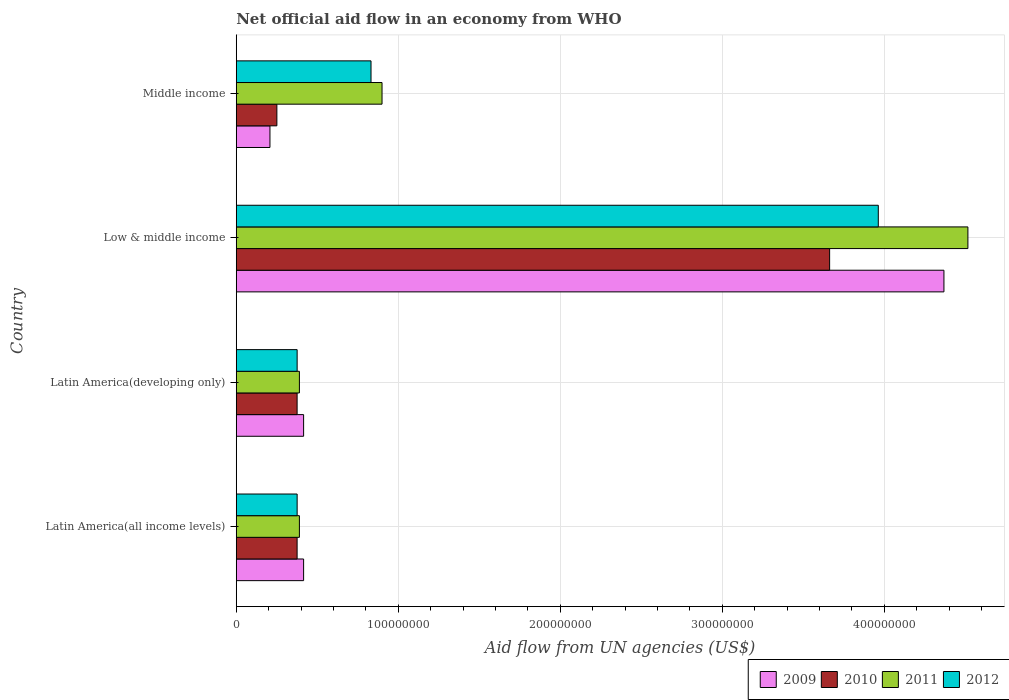How many different coloured bars are there?
Offer a very short reply. 4. Are the number of bars on each tick of the Y-axis equal?
Keep it short and to the point. Yes. What is the label of the 3rd group of bars from the top?
Ensure brevity in your answer.  Latin America(developing only). In how many cases, is the number of bars for a given country not equal to the number of legend labels?
Your answer should be very brief. 0. What is the net official aid flow in 2010 in Middle income?
Offer a terse response. 2.51e+07. Across all countries, what is the maximum net official aid flow in 2009?
Provide a short and direct response. 4.37e+08. Across all countries, what is the minimum net official aid flow in 2009?
Provide a short and direct response. 2.08e+07. In which country was the net official aid flow in 2011 maximum?
Your answer should be compact. Low & middle income. In which country was the net official aid flow in 2011 minimum?
Keep it short and to the point. Latin America(all income levels). What is the total net official aid flow in 2009 in the graph?
Provide a short and direct response. 5.41e+08. What is the difference between the net official aid flow in 2010 in Latin America(developing only) and that in Middle income?
Give a very brief answer. 1.25e+07. What is the difference between the net official aid flow in 2010 in Latin America(all income levels) and the net official aid flow in 2011 in Low & middle income?
Ensure brevity in your answer.  -4.14e+08. What is the average net official aid flow in 2009 per country?
Ensure brevity in your answer.  1.35e+08. What is the difference between the net official aid flow in 2010 and net official aid flow in 2009 in Low & middle income?
Keep it short and to the point. -7.06e+07. What is the ratio of the net official aid flow in 2009 in Low & middle income to that in Middle income?
Keep it short and to the point. 21. Is the net official aid flow in 2009 in Latin America(all income levels) less than that in Latin America(developing only)?
Your response must be concise. No. Is the difference between the net official aid flow in 2010 in Low & middle income and Middle income greater than the difference between the net official aid flow in 2009 in Low & middle income and Middle income?
Make the answer very short. No. What is the difference between the highest and the second highest net official aid flow in 2009?
Keep it short and to the point. 3.95e+08. What is the difference between the highest and the lowest net official aid flow in 2012?
Your answer should be compact. 3.59e+08. Is the sum of the net official aid flow in 2009 in Latin America(developing only) and Middle income greater than the maximum net official aid flow in 2011 across all countries?
Give a very brief answer. No. Is it the case that in every country, the sum of the net official aid flow in 2012 and net official aid flow in 2010 is greater than the sum of net official aid flow in 2011 and net official aid flow in 2009?
Provide a succinct answer. No. How many bars are there?
Offer a terse response. 16. Are all the bars in the graph horizontal?
Your answer should be very brief. Yes. Are the values on the major ticks of X-axis written in scientific E-notation?
Offer a very short reply. No. Does the graph contain any zero values?
Provide a short and direct response. No. Where does the legend appear in the graph?
Keep it short and to the point. Bottom right. What is the title of the graph?
Make the answer very short. Net official aid flow in an economy from WHO. What is the label or title of the X-axis?
Your response must be concise. Aid flow from UN agencies (US$). What is the Aid flow from UN agencies (US$) of 2009 in Latin America(all income levels)?
Make the answer very short. 4.16e+07. What is the Aid flow from UN agencies (US$) in 2010 in Latin America(all income levels)?
Offer a terse response. 3.76e+07. What is the Aid flow from UN agencies (US$) in 2011 in Latin America(all income levels)?
Keep it short and to the point. 3.90e+07. What is the Aid flow from UN agencies (US$) of 2012 in Latin America(all income levels)?
Your answer should be compact. 3.76e+07. What is the Aid flow from UN agencies (US$) of 2009 in Latin America(developing only)?
Keep it short and to the point. 4.16e+07. What is the Aid flow from UN agencies (US$) in 2010 in Latin America(developing only)?
Offer a terse response. 3.76e+07. What is the Aid flow from UN agencies (US$) in 2011 in Latin America(developing only)?
Ensure brevity in your answer.  3.90e+07. What is the Aid flow from UN agencies (US$) of 2012 in Latin America(developing only)?
Give a very brief answer. 3.76e+07. What is the Aid flow from UN agencies (US$) of 2009 in Low & middle income?
Provide a succinct answer. 4.37e+08. What is the Aid flow from UN agencies (US$) in 2010 in Low & middle income?
Offer a terse response. 3.66e+08. What is the Aid flow from UN agencies (US$) of 2011 in Low & middle income?
Your response must be concise. 4.52e+08. What is the Aid flow from UN agencies (US$) in 2012 in Low & middle income?
Make the answer very short. 3.96e+08. What is the Aid flow from UN agencies (US$) of 2009 in Middle income?
Make the answer very short. 2.08e+07. What is the Aid flow from UN agencies (US$) of 2010 in Middle income?
Your response must be concise. 2.51e+07. What is the Aid flow from UN agencies (US$) in 2011 in Middle income?
Give a very brief answer. 9.00e+07. What is the Aid flow from UN agencies (US$) of 2012 in Middle income?
Offer a very short reply. 8.32e+07. Across all countries, what is the maximum Aid flow from UN agencies (US$) of 2009?
Ensure brevity in your answer.  4.37e+08. Across all countries, what is the maximum Aid flow from UN agencies (US$) of 2010?
Your answer should be very brief. 3.66e+08. Across all countries, what is the maximum Aid flow from UN agencies (US$) of 2011?
Offer a very short reply. 4.52e+08. Across all countries, what is the maximum Aid flow from UN agencies (US$) in 2012?
Your answer should be compact. 3.96e+08. Across all countries, what is the minimum Aid flow from UN agencies (US$) in 2009?
Ensure brevity in your answer.  2.08e+07. Across all countries, what is the minimum Aid flow from UN agencies (US$) of 2010?
Provide a succinct answer. 2.51e+07. Across all countries, what is the minimum Aid flow from UN agencies (US$) in 2011?
Your answer should be very brief. 3.90e+07. Across all countries, what is the minimum Aid flow from UN agencies (US$) of 2012?
Make the answer very short. 3.76e+07. What is the total Aid flow from UN agencies (US$) of 2009 in the graph?
Your response must be concise. 5.41e+08. What is the total Aid flow from UN agencies (US$) of 2010 in the graph?
Offer a very short reply. 4.66e+08. What is the total Aid flow from UN agencies (US$) in 2011 in the graph?
Keep it short and to the point. 6.20e+08. What is the total Aid flow from UN agencies (US$) of 2012 in the graph?
Provide a short and direct response. 5.55e+08. What is the difference between the Aid flow from UN agencies (US$) of 2010 in Latin America(all income levels) and that in Latin America(developing only)?
Offer a terse response. 0. What is the difference between the Aid flow from UN agencies (US$) of 2009 in Latin America(all income levels) and that in Low & middle income?
Your answer should be very brief. -3.95e+08. What is the difference between the Aid flow from UN agencies (US$) of 2010 in Latin America(all income levels) and that in Low & middle income?
Your answer should be compact. -3.29e+08. What is the difference between the Aid flow from UN agencies (US$) in 2011 in Latin America(all income levels) and that in Low & middle income?
Provide a succinct answer. -4.13e+08. What is the difference between the Aid flow from UN agencies (US$) in 2012 in Latin America(all income levels) and that in Low & middle income?
Keep it short and to the point. -3.59e+08. What is the difference between the Aid flow from UN agencies (US$) in 2009 in Latin America(all income levels) and that in Middle income?
Your answer should be compact. 2.08e+07. What is the difference between the Aid flow from UN agencies (US$) of 2010 in Latin America(all income levels) and that in Middle income?
Ensure brevity in your answer.  1.25e+07. What is the difference between the Aid flow from UN agencies (US$) in 2011 in Latin America(all income levels) and that in Middle income?
Keep it short and to the point. -5.10e+07. What is the difference between the Aid flow from UN agencies (US$) of 2012 in Latin America(all income levels) and that in Middle income?
Provide a succinct answer. -4.56e+07. What is the difference between the Aid flow from UN agencies (US$) of 2009 in Latin America(developing only) and that in Low & middle income?
Your answer should be very brief. -3.95e+08. What is the difference between the Aid flow from UN agencies (US$) of 2010 in Latin America(developing only) and that in Low & middle income?
Offer a terse response. -3.29e+08. What is the difference between the Aid flow from UN agencies (US$) of 2011 in Latin America(developing only) and that in Low & middle income?
Offer a terse response. -4.13e+08. What is the difference between the Aid flow from UN agencies (US$) of 2012 in Latin America(developing only) and that in Low & middle income?
Your answer should be very brief. -3.59e+08. What is the difference between the Aid flow from UN agencies (US$) in 2009 in Latin America(developing only) and that in Middle income?
Keep it short and to the point. 2.08e+07. What is the difference between the Aid flow from UN agencies (US$) in 2010 in Latin America(developing only) and that in Middle income?
Give a very brief answer. 1.25e+07. What is the difference between the Aid flow from UN agencies (US$) in 2011 in Latin America(developing only) and that in Middle income?
Offer a very short reply. -5.10e+07. What is the difference between the Aid flow from UN agencies (US$) in 2012 in Latin America(developing only) and that in Middle income?
Ensure brevity in your answer.  -4.56e+07. What is the difference between the Aid flow from UN agencies (US$) in 2009 in Low & middle income and that in Middle income?
Your answer should be very brief. 4.16e+08. What is the difference between the Aid flow from UN agencies (US$) of 2010 in Low & middle income and that in Middle income?
Make the answer very short. 3.41e+08. What is the difference between the Aid flow from UN agencies (US$) in 2011 in Low & middle income and that in Middle income?
Your answer should be compact. 3.62e+08. What is the difference between the Aid flow from UN agencies (US$) of 2012 in Low & middle income and that in Middle income?
Ensure brevity in your answer.  3.13e+08. What is the difference between the Aid flow from UN agencies (US$) in 2009 in Latin America(all income levels) and the Aid flow from UN agencies (US$) in 2010 in Latin America(developing only)?
Offer a terse response. 4.01e+06. What is the difference between the Aid flow from UN agencies (US$) in 2009 in Latin America(all income levels) and the Aid flow from UN agencies (US$) in 2011 in Latin America(developing only)?
Offer a very short reply. 2.59e+06. What is the difference between the Aid flow from UN agencies (US$) in 2009 in Latin America(all income levels) and the Aid flow from UN agencies (US$) in 2012 in Latin America(developing only)?
Ensure brevity in your answer.  3.99e+06. What is the difference between the Aid flow from UN agencies (US$) in 2010 in Latin America(all income levels) and the Aid flow from UN agencies (US$) in 2011 in Latin America(developing only)?
Your answer should be compact. -1.42e+06. What is the difference between the Aid flow from UN agencies (US$) in 2010 in Latin America(all income levels) and the Aid flow from UN agencies (US$) in 2012 in Latin America(developing only)?
Ensure brevity in your answer.  -2.00e+04. What is the difference between the Aid flow from UN agencies (US$) in 2011 in Latin America(all income levels) and the Aid flow from UN agencies (US$) in 2012 in Latin America(developing only)?
Give a very brief answer. 1.40e+06. What is the difference between the Aid flow from UN agencies (US$) in 2009 in Latin America(all income levels) and the Aid flow from UN agencies (US$) in 2010 in Low & middle income?
Your answer should be compact. -3.25e+08. What is the difference between the Aid flow from UN agencies (US$) of 2009 in Latin America(all income levels) and the Aid flow from UN agencies (US$) of 2011 in Low & middle income?
Offer a very short reply. -4.10e+08. What is the difference between the Aid flow from UN agencies (US$) of 2009 in Latin America(all income levels) and the Aid flow from UN agencies (US$) of 2012 in Low & middle income?
Give a very brief answer. -3.55e+08. What is the difference between the Aid flow from UN agencies (US$) in 2010 in Latin America(all income levels) and the Aid flow from UN agencies (US$) in 2011 in Low & middle income?
Ensure brevity in your answer.  -4.14e+08. What is the difference between the Aid flow from UN agencies (US$) in 2010 in Latin America(all income levels) and the Aid flow from UN agencies (US$) in 2012 in Low & middle income?
Your response must be concise. -3.59e+08. What is the difference between the Aid flow from UN agencies (US$) of 2011 in Latin America(all income levels) and the Aid flow from UN agencies (US$) of 2012 in Low & middle income?
Keep it short and to the point. -3.57e+08. What is the difference between the Aid flow from UN agencies (US$) of 2009 in Latin America(all income levels) and the Aid flow from UN agencies (US$) of 2010 in Middle income?
Make the answer very short. 1.65e+07. What is the difference between the Aid flow from UN agencies (US$) in 2009 in Latin America(all income levels) and the Aid flow from UN agencies (US$) in 2011 in Middle income?
Give a very brief answer. -4.84e+07. What is the difference between the Aid flow from UN agencies (US$) in 2009 in Latin America(all income levels) and the Aid flow from UN agencies (US$) in 2012 in Middle income?
Give a very brief answer. -4.16e+07. What is the difference between the Aid flow from UN agencies (US$) of 2010 in Latin America(all income levels) and the Aid flow from UN agencies (US$) of 2011 in Middle income?
Offer a very short reply. -5.24e+07. What is the difference between the Aid flow from UN agencies (US$) of 2010 in Latin America(all income levels) and the Aid flow from UN agencies (US$) of 2012 in Middle income?
Offer a terse response. -4.56e+07. What is the difference between the Aid flow from UN agencies (US$) of 2011 in Latin America(all income levels) and the Aid flow from UN agencies (US$) of 2012 in Middle income?
Offer a very short reply. -4.42e+07. What is the difference between the Aid flow from UN agencies (US$) in 2009 in Latin America(developing only) and the Aid flow from UN agencies (US$) in 2010 in Low & middle income?
Offer a terse response. -3.25e+08. What is the difference between the Aid flow from UN agencies (US$) in 2009 in Latin America(developing only) and the Aid flow from UN agencies (US$) in 2011 in Low & middle income?
Your response must be concise. -4.10e+08. What is the difference between the Aid flow from UN agencies (US$) of 2009 in Latin America(developing only) and the Aid flow from UN agencies (US$) of 2012 in Low & middle income?
Make the answer very short. -3.55e+08. What is the difference between the Aid flow from UN agencies (US$) of 2010 in Latin America(developing only) and the Aid flow from UN agencies (US$) of 2011 in Low & middle income?
Make the answer very short. -4.14e+08. What is the difference between the Aid flow from UN agencies (US$) in 2010 in Latin America(developing only) and the Aid flow from UN agencies (US$) in 2012 in Low & middle income?
Ensure brevity in your answer.  -3.59e+08. What is the difference between the Aid flow from UN agencies (US$) in 2011 in Latin America(developing only) and the Aid flow from UN agencies (US$) in 2012 in Low & middle income?
Keep it short and to the point. -3.57e+08. What is the difference between the Aid flow from UN agencies (US$) in 2009 in Latin America(developing only) and the Aid flow from UN agencies (US$) in 2010 in Middle income?
Ensure brevity in your answer.  1.65e+07. What is the difference between the Aid flow from UN agencies (US$) of 2009 in Latin America(developing only) and the Aid flow from UN agencies (US$) of 2011 in Middle income?
Offer a very short reply. -4.84e+07. What is the difference between the Aid flow from UN agencies (US$) in 2009 in Latin America(developing only) and the Aid flow from UN agencies (US$) in 2012 in Middle income?
Your response must be concise. -4.16e+07. What is the difference between the Aid flow from UN agencies (US$) in 2010 in Latin America(developing only) and the Aid flow from UN agencies (US$) in 2011 in Middle income?
Ensure brevity in your answer.  -5.24e+07. What is the difference between the Aid flow from UN agencies (US$) in 2010 in Latin America(developing only) and the Aid flow from UN agencies (US$) in 2012 in Middle income?
Offer a terse response. -4.56e+07. What is the difference between the Aid flow from UN agencies (US$) in 2011 in Latin America(developing only) and the Aid flow from UN agencies (US$) in 2012 in Middle income?
Give a very brief answer. -4.42e+07. What is the difference between the Aid flow from UN agencies (US$) in 2009 in Low & middle income and the Aid flow from UN agencies (US$) in 2010 in Middle income?
Provide a succinct answer. 4.12e+08. What is the difference between the Aid flow from UN agencies (US$) of 2009 in Low & middle income and the Aid flow from UN agencies (US$) of 2011 in Middle income?
Ensure brevity in your answer.  3.47e+08. What is the difference between the Aid flow from UN agencies (US$) in 2009 in Low & middle income and the Aid flow from UN agencies (US$) in 2012 in Middle income?
Give a very brief answer. 3.54e+08. What is the difference between the Aid flow from UN agencies (US$) of 2010 in Low & middle income and the Aid flow from UN agencies (US$) of 2011 in Middle income?
Your answer should be very brief. 2.76e+08. What is the difference between the Aid flow from UN agencies (US$) in 2010 in Low & middle income and the Aid flow from UN agencies (US$) in 2012 in Middle income?
Your answer should be compact. 2.83e+08. What is the difference between the Aid flow from UN agencies (US$) in 2011 in Low & middle income and the Aid flow from UN agencies (US$) in 2012 in Middle income?
Offer a very short reply. 3.68e+08. What is the average Aid flow from UN agencies (US$) of 2009 per country?
Offer a very short reply. 1.35e+08. What is the average Aid flow from UN agencies (US$) in 2010 per country?
Give a very brief answer. 1.17e+08. What is the average Aid flow from UN agencies (US$) in 2011 per country?
Your answer should be very brief. 1.55e+08. What is the average Aid flow from UN agencies (US$) in 2012 per country?
Offer a very short reply. 1.39e+08. What is the difference between the Aid flow from UN agencies (US$) of 2009 and Aid flow from UN agencies (US$) of 2010 in Latin America(all income levels)?
Provide a succinct answer. 4.01e+06. What is the difference between the Aid flow from UN agencies (US$) in 2009 and Aid flow from UN agencies (US$) in 2011 in Latin America(all income levels)?
Provide a short and direct response. 2.59e+06. What is the difference between the Aid flow from UN agencies (US$) of 2009 and Aid flow from UN agencies (US$) of 2012 in Latin America(all income levels)?
Keep it short and to the point. 3.99e+06. What is the difference between the Aid flow from UN agencies (US$) in 2010 and Aid flow from UN agencies (US$) in 2011 in Latin America(all income levels)?
Offer a very short reply. -1.42e+06. What is the difference between the Aid flow from UN agencies (US$) of 2010 and Aid flow from UN agencies (US$) of 2012 in Latin America(all income levels)?
Your answer should be very brief. -2.00e+04. What is the difference between the Aid flow from UN agencies (US$) in 2011 and Aid flow from UN agencies (US$) in 2012 in Latin America(all income levels)?
Ensure brevity in your answer.  1.40e+06. What is the difference between the Aid flow from UN agencies (US$) in 2009 and Aid flow from UN agencies (US$) in 2010 in Latin America(developing only)?
Give a very brief answer. 4.01e+06. What is the difference between the Aid flow from UN agencies (US$) of 2009 and Aid flow from UN agencies (US$) of 2011 in Latin America(developing only)?
Provide a succinct answer. 2.59e+06. What is the difference between the Aid flow from UN agencies (US$) in 2009 and Aid flow from UN agencies (US$) in 2012 in Latin America(developing only)?
Give a very brief answer. 3.99e+06. What is the difference between the Aid flow from UN agencies (US$) in 2010 and Aid flow from UN agencies (US$) in 2011 in Latin America(developing only)?
Make the answer very short. -1.42e+06. What is the difference between the Aid flow from UN agencies (US$) in 2011 and Aid flow from UN agencies (US$) in 2012 in Latin America(developing only)?
Your response must be concise. 1.40e+06. What is the difference between the Aid flow from UN agencies (US$) of 2009 and Aid flow from UN agencies (US$) of 2010 in Low & middle income?
Provide a succinct answer. 7.06e+07. What is the difference between the Aid flow from UN agencies (US$) of 2009 and Aid flow from UN agencies (US$) of 2011 in Low & middle income?
Provide a succinct answer. -1.48e+07. What is the difference between the Aid flow from UN agencies (US$) in 2009 and Aid flow from UN agencies (US$) in 2012 in Low & middle income?
Keep it short and to the point. 4.05e+07. What is the difference between the Aid flow from UN agencies (US$) of 2010 and Aid flow from UN agencies (US$) of 2011 in Low & middle income?
Provide a short and direct response. -8.54e+07. What is the difference between the Aid flow from UN agencies (US$) of 2010 and Aid flow from UN agencies (US$) of 2012 in Low & middle income?
Offer a terse response. -3.00e+07. What is the difference between the Aid flow from UN agencies (US$) in 2011 and Aid flow from UN agencies (US$) in 2012 in Low & middle income?
Provide a short and direct response. 5.53e+07. What is the difference between the Aid flow from UN agencies (US$) in 2009 and Aid flow from UN agencies (US$) in 2010 in Middle income?
Keep it short and to the point. -4.27e+06. What is the difference between the Aid flow from UN agencies (US$) of 2009 and Aid flow from UN agencies (US$) of 2011 in Middle income?
Provide a succinct answer. -6.92e+07. What is the difference between the Aid flow from UN agencies (US$) of 2009 and Aid flow from UN agencies (US$) of 2012 in Middle income?
Provide a short and direct response. -6.24e+07. What is the difference between the Aid flow from UN agencies (US$) of 2010 and Aid flow from UN agencies (US$) of 2011 in Middle income?
Offer a very short reply. -6.49e+07. What is the difference between the Aid flow from UN agencies (US$) in 2010 and Aid flow from UN agencies (US$) in 2012 in Middle income?
Your answer should be compact. -5.81e+07. What is the difference between the Aid flow from UN agencies (US$) in 2011 and Aid flow from UN agencies (US$) in 2012 in Middle income?
Keep it short and to the point. 6.80e+06. What is the ratio of the Aid flow from UN agencies (US$) in 2009 in Latin America(all income levels) to that in Latin America(developing only)?
Ensure brevity in your answer.  1. What is the ratio of the Aid flow from UN agencies (US$) of 2009 in Latin America(all income levels) to that in Low & middle income?
Provide a short and direct response. 0.1. What is the ratio of the Aid flow from UN agencies (US$) of 2010 in Latin America(all income levels) to that in Low & middle income?
Keep it short and to the point. 0.1. What is the ratio of the Aid flow from UN agencies (US$) in 2011 in Latin America(all income levels) to that in Low & middle income?
Provide a short and direct response. 0.09. What is the ratio of the Aid flow from UN agencies (US$) in 2012 in Latin America(all income levels) to that in Low & middle income?
Make the answer very short. 0.09. What is the ratio of the Aid flow from UN agencies (US$) of 2009 in Latin America(all income levels) to that in Middle income?
Give a very brief answer. 2. What is the ratio of the Aid flow from UN agencies (US$) of 2010 in Latin America(all income levels) to that in Middle income?
Offer a terse response. 1.5. What is the ratio of the Aid flow from UN agencies (US$) in 2011 in Latin America(all income levels) to that in Middle income?
Keep it short and to the point. 0.43. What is the ratio of the Aid flow from UN agencies (US$) of 2012 in Latin America(all income levels) to that in Middle income?
Your answer should be very brief. 0.45. What is the ratio of the Aid flow from UN agencies (US$) of 2009 in Latin America(developing only) to that in Low & middle income?
Ensure brevity in your answer.  0.1. What is the ratio of the Aid flow from UN agencies (US$) of 2010 in Latin America(developing only) to that in Low & middle income?
Offer a terse response. 0.1. What is the ratio of the Aid flow from UN agencies (US$) in 2011 in Latin America(developing only) to that in Low & middle income?
Keep it short and to the point. 0.09. What is the ratio of the Aid flow from UN agencies (US$) in 2012 in Latin America(developing only) to that in Low & middle income?
Your answer should be very brief. 0.09. What is the ratio of the Aid flow from UN agencies (US$) of 2009 in Latin America(developing only) to that in Middle income?
Your answer should be very brief. 2. What is the ratio of the Aid flow from UN agencies (US$) of 2010 in Latin America(developing only) to that in Middle income?
Provide a succinct answer. 1.5. What is the ratio of the Aid flow from UN agencies (US$) of 2011 in Latin America(developing only) to that in Middle income?
Make the answer very short. 0.43. What is the ratio of the Aid flow from UN agencies (US$) in 2012 in Latin America(developing only) to that in Middle income?
Keep it short and to the point. 0.45. What is the ratio of the Aid flow from UN agencies (US$) of 2009 in Low & middle income to that in Middle income?
Keep it short and to the point. 21. What is the ratio of the Aid flow from UN agencies (US$) of 2010 in Low & middle income to that in Middle income?
Offer a terse response. 14.61. What is the ratio of the Aid flow from UN agencies (US$) in 2011 in Low & middle income to that in Middle income?
Offer a terse response. 5.02. What is the ratio of the Aid flow from UN agencies (US$) of 2012 in Low & middle income to that in Middle income?
Offer a very short reply. 4.76. What is the difference between the highest and the second highest Aid flow from UN agencies (US$) of 2009?
Provide a succinct answer. 3.95e+08. What is the difference between the highest and the second highest Aid flow from UN agencies (US$) in 2010?
Your response must be concise. 3.29e+08. What is the difference between the highest and the second highest Aid flow from UN agencies (US$) of 2011?
Provide a short and direct response. 3.62e+08. What is the difference between the highest and the second highest Aid flow from UN agencies (US$) of 2012?
Offer a terse response. 3.13e+08. What is the difference between the highest and the lowest Aid flow from UN agencies (US$) of 2009?
Your answer should be very brief. 4.16e+08. What is the difference between the highest and the lowest Aid flow from UN agencies (US$) in 2010?
Offer a terse response. 3.41e+08. What is the difference between the highest and the lowest Aid flow from UN agencies (US$) in 2011?
Ensure brevity in your answer.  4.13e+08. What is the difference between the highest and the lowest Aid flow from UN agencies (US$) in 2012?
Keep it short and to the point. 3.59e+08. 